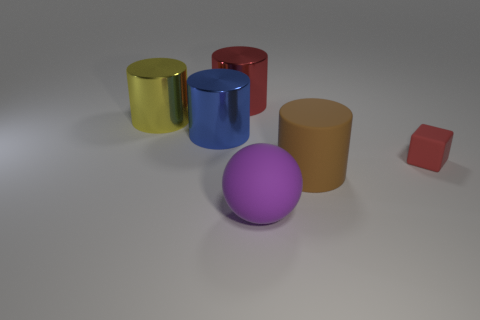Do the tiny block and the big metallic cylinder that is on the right side of the big blue metallic cylinder have the same color?
Offer a very short reply. Yes. What number of objects are both right of the brown thing and left of the blue metallic object?
Offer a very short reply. 0. What number of other objects are the same color as the matte ball?
Your answer should be very brief. 0. There is a red object behind the cube; what is its shape?
Provide a succinct answer. Cylinder. Are the large purple ball and the large blue thing made of the same material?
Your response must be concise. No. Are there any other things that are the same size as the red block?
Offer a very short reply. No. There is a big red cylinder; how many large blue metal cylinders are behind it?
Your answer should be compact. 0. What shape is the big matte thing that is in front of the cylinder that is right of the large red metal thing?
Give a very brief answer. Sphere. Is there anything else that is the same shape as the purple matte object?
Provide a succinct answer. No. Is the number of big red shiny objects on the left side of the red block greater than the number of large green things?
Keep it short and to the point. Yes. 